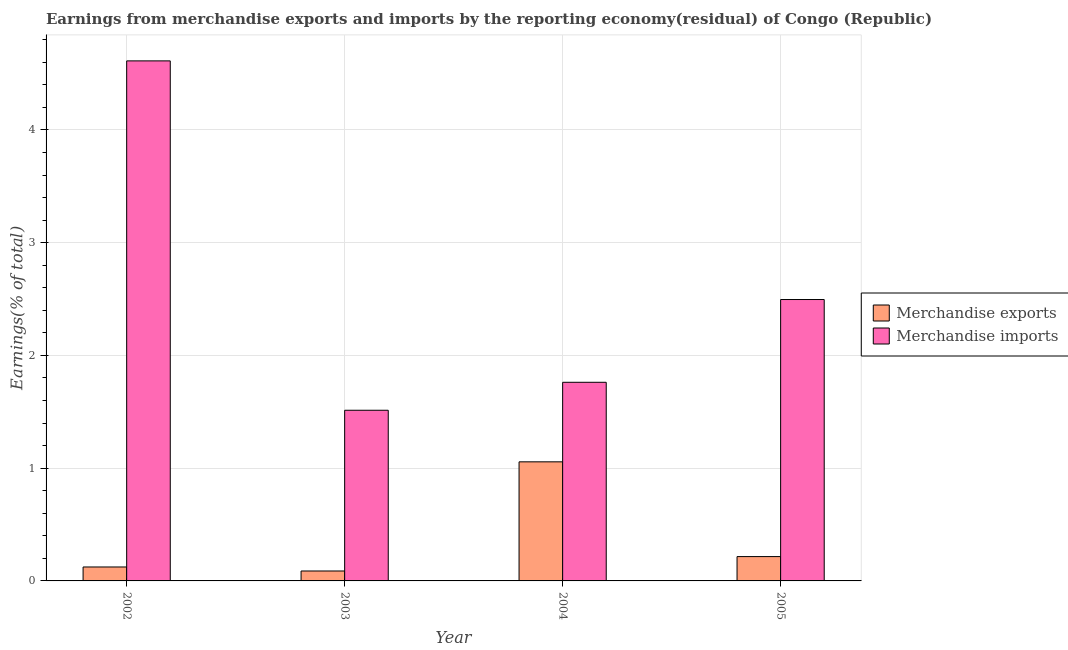How many different coloured bars are there?
Ensure brevity in your answer.  2. How many groups of bars are there?
Offer a terse response. 4. Are the number of bars on each tick of the X-axis equal?
Offer a very short reply. Yes. How many bars are there on the 1st tick from the left?
Your response must be concise. 2. In how many cases, is the number of bars for a given year not equal to the number of legend labels?
Your answer should be very brief. 0. What is the earnings from merchandise exports in 2002?
Keep it short and to the point. 0.12. Across all years, what is the maximum earnings from merchandise exports?
Ensure brevity in your answer.  1.06. Across all years, what is the minimum earnings from merchandise imports?
Your answer should be very brief. 1.51. In which year was the earnings from merchandise exports minimum?
Offer a very short reply. 2003. What is the total earnings from merchandise exports in the graph?
Your answer should be very brief. 1.48. What is the difference between the earnings from merchandise imports in 2003 and that in 2005?
Make the answer very short. -0.98. What is the difference between the earnings from merchandise imports in 2005 and the earnings from merchandise exports in 2004?
Provide a short and direct response. 0.73. What is the average earnings from merchandise exports per year?
Your answer should be very brief. 0.37. In the year 2003, what is the difference between the earnings from merchandise imports and earnings from merchandise exports?
Offer a very short reply. 0. What is the ratio of the earnings from merchandise imports in 2003 to that in 2004?
Your answer should be compact. 0.86. Is the earnings from merchandise imports in 2002 less than that in 2003?
Offer a terse response. No. What is the difference between the highest and the second highest earnings from merchandise exports?
Provide a short and direct response. 0.84. What is the difference between the highest and the lowest earnings from merchandise imports?
Your answer should be compact. 3.1. Is the sum of the earnings from merchandise imports in 2002 and 2004 greater than the maximum earnings from merchandise exports across all years?
Offer a very short reply. Yes. What does the 2nd bar from the left in 2003 represents?
Give a very brief answer. Merchandise imports. Are all the bars in the graph horizontal?
Provide a short and direct response. No. How many years are there in the graph?
Give a very brief answer. 4. What is the difference between two consecutive major ticks on the Y-axis?
Your answer should be very brief. 1. Are the values on the major ticks of Y-axis written in scientific E-notation?
Offer a very short reply. No. Does the graph contain any zero values?
Keep it short and to the point. No. Does the graph contain grids?
Offer a very short reply. Yes. How are the legend labels stacked?
Your answer should be compact. Vertical. What is the title of the graph?
Provide a succinct answer. Earnings from merchandise exports and imports by the reporting economy(residual) of Congo (Republic). What is the label or title of the X-axis?
Give a very brief answer. Year. What is the label or title of the Y-axis?
Ensure brevity in your answer.  Earnings(% of total). What is the Earnings(% of total) of Merchandise exports in 2002?
Keep it short and to the point. 0.12. What is the Earnings(% of total) of Merchandise imports in 2002?
Ensure brevity in your answer.  4.61. What is the Earnings(% of total) of Merchandise exports in 2003?
Your answer should be very brief. 0.09. What is the Earnings(% of total) in Merchandise imports in 2003?
Offer a very short reply. 1.51. What is the Earnings(% of total) in Merchandise exports in 2004?
Offer a terse response. 1.06. What is the Earnings(% of total) of Merchandise imports in 2004?
Your response must be concise. 1.76. What is the Earnings(% of total) in Merchandise exports in 2005?
Your answer should be compact. 0.22. What is the Earnings(% of total) in Merchandise imports in 2005?
Provide a short and direct response. 2.5. Across all years, what is the maximum Earnings(% of total) of Merchandise exports?
Offer a very short reply. 1.06. Across all years, what is the maximum Earnings(% of total) in Merchandise imports?
Ensure brevity in your answer.  4.61. Across all years, what is the minimum Earnings(% of total) in Merchandise exports?
Offer a very short reply. 0.09. Across all years, what is the minimum Earnings(% of total) in Merchandise imports?
Your response must be concise. 1.51. What is the total Earnings(% of total) in Merchandise exports in the graph?
Make the answer very short. 1.48. What is the total Earnings(% of total) in Merchandise imports in the graph?
Provide a short and direct response. 10.38. What is the difference between the Earnings(% of total) of Merchandise exports in 2002 and that in 2003?
Make the answer very short. 0.04. What is the difference between the Earnings(% of total) in Merchandise imports in 2002 and that in 2003?
Offer a terse response. 3.1. What is the difference between the Earnings(% of total) of Merchandise exports in 2002 and that in 2004?
Your answer should be compact. -0.93. What is the difference between the Earnings(% of total) in Merchandise imports in 2002 and that in 2004?
Your answer should be compact. 2.85. What is the difference between the Earnings(% of total) of Merchandise exports in 2002 and that in 2005?
Your answer should be compact. -0.09. What is the difference between the Earnings(% of total) in Merchandise imports in 2002 and that in 2005?
Give a very brief answer. 2.12. What is the difference between the Earnings(% of total) in Merchandise exports in 2003 and that in 2004?
Provide a short and direct response. -0.97. What is the difference between the Earnings(% of total) in Merchandise imports in 2003 and that in 2004?
Make the answer very short. -0.25. What is the difference between the Earnings(% of total) in Merchandise exports in 2003 and that in 2005?
Offer a terse response. -0.13. What is the difference between the Earnings(% of total) of Merchandise imports in 2003 and that in 2005?
Offer a terse response. -0.98. What is the difference between the Earnings(% of total) of Merchandise exports in 2004 and that in 2005?
Provide a succinct answer. 0.84. What is the difference between the Earnings(% of total) in Merchandise imports in 2004 and that in 2005?
Offer a very short reply. -0.73. What is the difference between the Earnings(% of total) in Merchandise exports in 2002 and the Earnings(% of total) in Merchandise imports in 2003?
Give a very brief answer. -1.39. What is the difference between the Earnings(% of total) of Merchandise exports in 2002 and the Earnings(% of total) of Merchandise imports in 2004?
Your response must be concise. -1.64. What is the difference between the Earnings(% of total) of Merchandise exports in 2002 and the Earnings(% of total) of Merchandise imports in 2005?
Ensure brevity in your answer.  -2.37. What is the difference between the Earnings(% of total) in Merchandise exports in 2003 and the Earnings(% of total) in Merchandise imports in 2004?
Provide a succinct answer. -1.67. What is the difference between the Earnings(% of total) in Merchandise exports in 2003 and the Earnings(% of total) in Merchandise imports in 2005?
Provide a succinct answer. -2.41. What is the difference between the Earnings(% of total) in Merchandise exports in 2004 and the Earnings(% of total) in Merchandise imports in 2005?
Offer a terse response. -1.44. What is the average Earnings(% of total) in Merchandise exports per year?
Offer a terse response. 0.37. What is the average Earnings(% of total) of Merchandise imports per year?
Offer a terse response. 2.6. In the year 2002, what is the difference between the Earnings(% of total) in Merchandise exports and Earnings(% of total) in Merchandise imports?
Your response must be concise. -4.49. In the year 2003, what is the difference between the Earnings(% of total) in Merchandise exports and Earnings(% of total) in Merchandise imports?
Give a very brief answer. -1.43. In the year 2004, what is the difference between the Earnings(% of total) of Merchandise exports and Earnings(% of total) of Merchandise imports?
Offer a very short reply. -0.71. In the year 2005, what is the difference between the Earnings(% of total) in Merchandise exports and Earnings(% of total) in Merchandise imports?
Keep it short and to the point. -2.28. What is the ratio of the Earnings(% of total) of Merchandise exports in 2002 to that in 2003?
Provide a short and direct response. 1.4. What is the ratio of the Earnings(% of total) of Merchandise imports in 2002 to that in 2003?
Ensure brevity in your answer.  3.05. What is the ratio of the Earnings(% of total) in Merchandise exports in 2002 to that in 2004?
Keep it short and to the point. 0.12. What is the ratio of the Earnings(% of total) in Merchandise imports in 2002 to that in 2004?
Ensure brevity in your answer.  2.62. What is the ratio of the Earnings(% of total) in Merchandise exports in 2002 to that in 2005?
Offer a terse response. 0.57. What is the ratio of the Earnings(% of total) of Merchandise imports in 2002 to that in 2005?
Ensure brevity in your answer.  1.85. What is the ratio of the Earnings(% of total) of Merchandise exports in 2003 to that in 2004?
Your answer should be compact. 0.08. What is the ratio of the Earnings(% of total) in Merchandise imports in 2003 to that in 2004?
Your answer should be compact. 0.86. What is the ratio of the Earnings(% of total) of Merchandise exports in 2003 to that in 2005?
Your answer should be very brief. 0.41. What is the ratio of the Earnings(% of total) in Merchandise imports in 2003 to that in 2005?
Your answer should be compact. 0.61. What is the ratio of the Earnings(% of total) of Merchandise exports in 2004 to that in 2005?
Your answer should be compact. 4.89. What is the ratio of the Earnings(% of total) in Merchandise imports in 2004 to that in 2005?
Ensure brevity in your answer.  0.71. What is the difference between the highest and the second highest Earnings(% of total) in Merchandise exports?
Provide a succinct answer. 0.84. What is the difference between the highest and the second highest Earnings(% of total) of Merchandise imports?
Ensure brevity in your answer.  2.12. What is the difference between the highest and the lowest Earnings(% of total) in Merchandise exports?
Your response must be concise. 0.97. What is the difference between the highest and the lowest Earnings(% of total) in Merchandise imports?
Offer a very short reply. 3.1. 